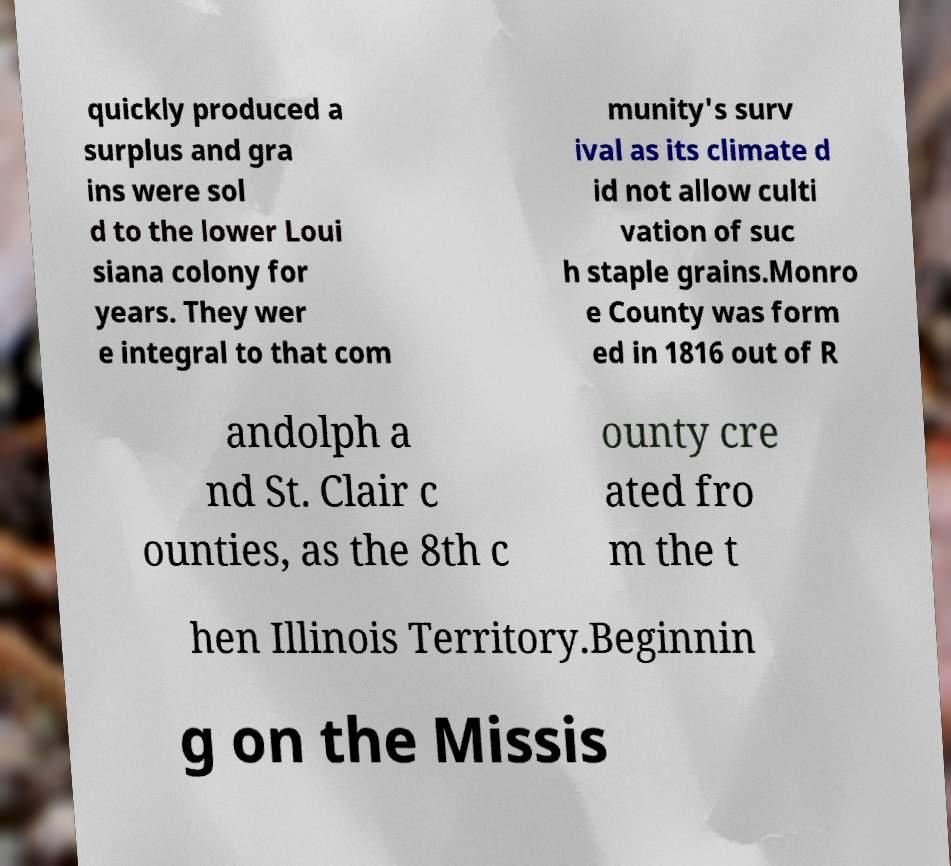For documentation purposes, I need the text within this image transcribed. Could you provide that? quickly produced a surplus and gra ins were sol d to the lower Loui siana colony for years. They wer e integral to that com munity's surv ival as its climate d id not allow culti vation of suc h staple grains.Monro e County was form ed in 1816 out of R andolph a nd St. Clair c ounties, as the 8th c ounty cre ated fro m the t hen Illinois Territory.Beginnin g on the Missis 